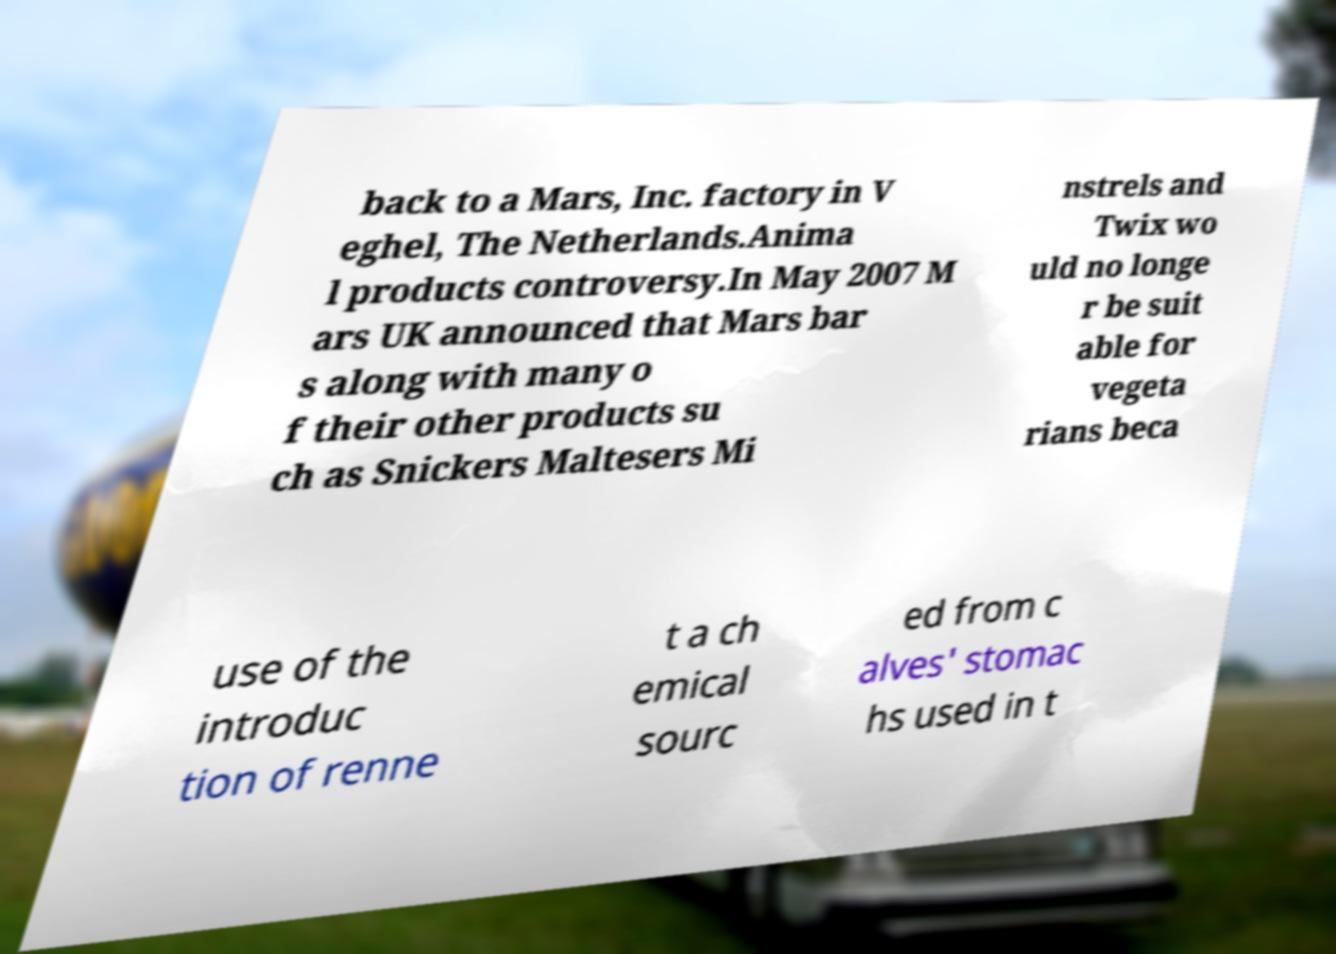Could you assist in decoding the text presented in this image and type it out clearly? back to a Mars, Inc. factory in V eghel, The Netherlands.Anima l products controversy.In May 2007 M ars UK announced that Mars bar s along with many o f their other products su ch as Snickers Maltesers Mi nstrels and Twix wo uld no longe r be suit able for vegeta rians beca use of the introduc tion of renne t a ch emical sourc ed from c alves' stomac hs used in t 